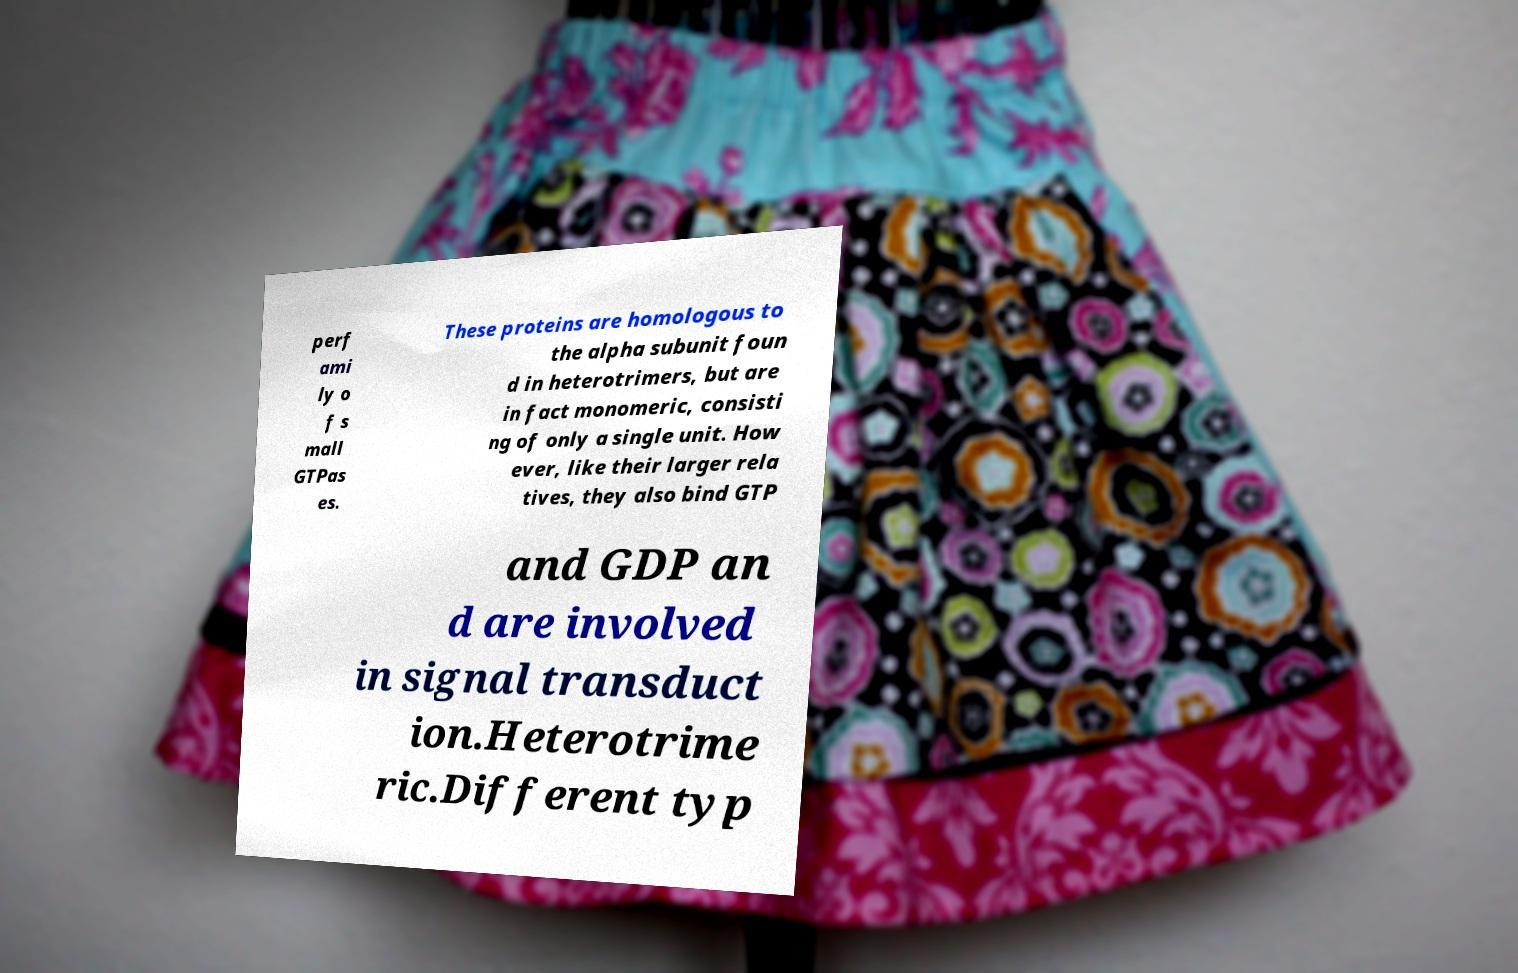Could you extract and type out the text from this image? perf ami ly o f s mall GTPas es. These proteins are homologous to the alpha subunit foun d in heterotrimers, but are in fact monomeric, consisti ng of only a single unit. How ever, like their larger rela tives, they also bind GTP and GDP an d are involved in signal transduct ion.Heterotrime ric.Different typ 